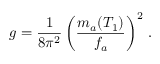Convert formula to latex. <formula><loc_0><loc_0><loc_500><loc_500>g = \frac { 1 } { 8 \pi ^ { 2 } } \left ( \frac { m _ { a } ( T _ { 1 } ) } { f _ { a } } \right ) ^ { 2 } \, .</formula> 